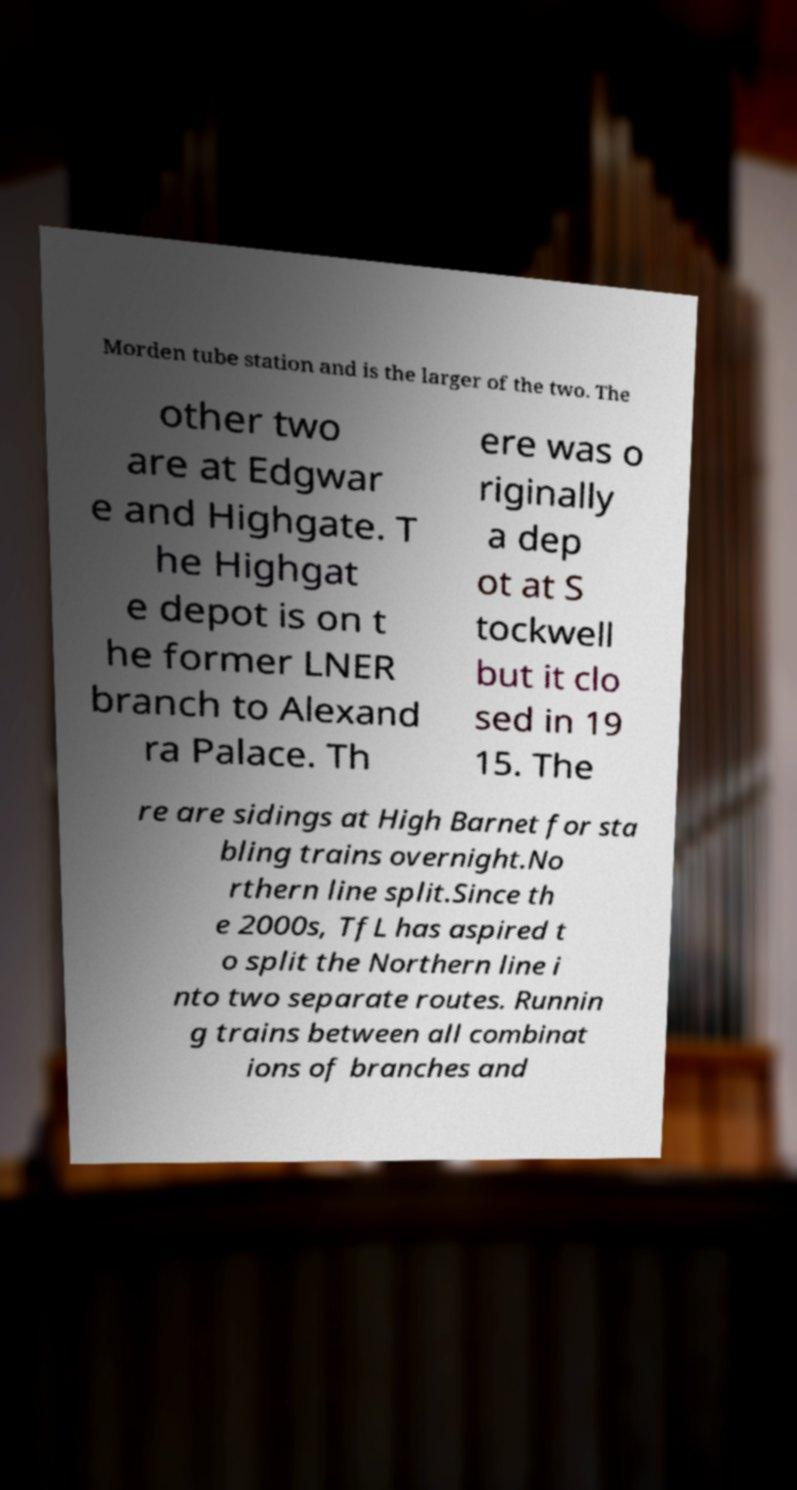Please read and relay the text visible in this image. What does it say? Morden tube station and is the larger of the two. The other two are at Edgwar e and Highgate. T he Highgat e depot is on t he former LNER branch to Alexand ra Palace. Th ere was o riginally a dep ot at S tockwell but it clo sed in 19 15. The re are sidings at High Barnet for sta bling trains overnight.No rthern line split.Since th e 2000s, TfL has aspired t o split the Northern line i nto two separate routes. Runnin g trains between all combinat ions of branches and 